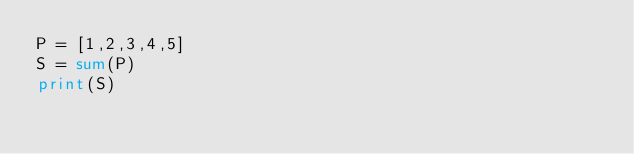<code> <loc_0><loc_0><loc_500><loc_500><_Python_>P = [1,2,3,4,5]
S = sum(P)
print(S)</code> 